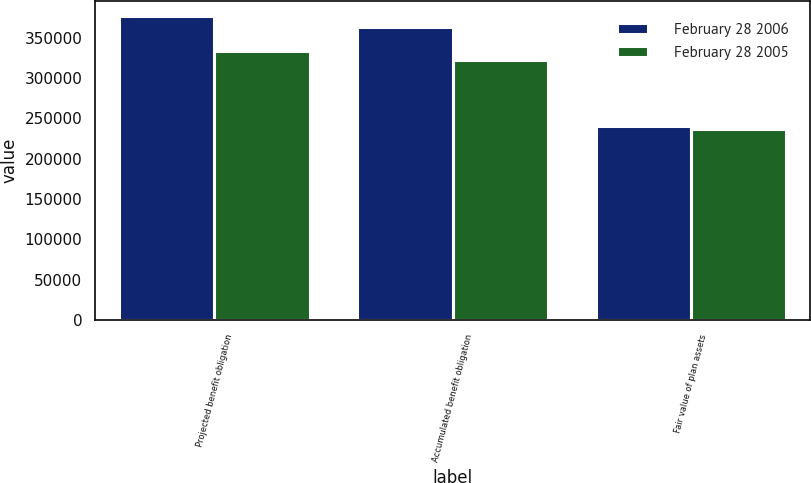Convert chart. <chart><loc_0><loc_0><loc_500><loc_500><stacked_bar_chart><ecel><fcel>Projected benefit obligation<fcel>Accumulated benefit obligation<fcel>Fair value of plan assets<nl><fcel>February 28 2006<fcel>376467<fcel>363015<fcel>240313<nl><fcel>February 28 2005<fcel>332952<fcel>321963<fcel>236145<nl></chart> 